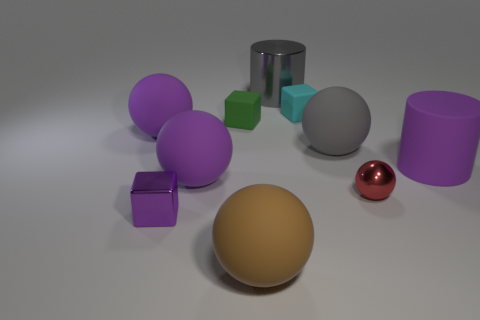What material is the green object?
Make the answer very short. Rubber. What is the material of the gray object that is on the right side of the large gray metal cylinder?
Provide a short and direct response. Rubber. Is there any other thing that is made of the same material as the red ball?
Your response must be concise. Yes. Is the number of big cylinders that are in front of the rubber cylinder greater than the number of tiny gray cylinders?
Your response must be concise. No. Are there any small cyan matte cubes on the right side of the tiny matte thing right of the gray thing that is behind the small green thing?
Make the answer very short. No. Are there any blocks left of the brown sphere?
Your answer should be very brief. Yes. How many matte blocks have the same color as the large shiny cylinder?
Your answer should be compact. 0. There is a gray thing that is the same material as the large brown thing; what size is it?
Provide a succinct answer. Large. There is a cube in front of the big purple sphere that is in front of the cylinder right of the gray sphere; what size is it?
Keep it short and to the point. Small. What is the size of the cylinder in front of the large gray rubber sphere?
Make the answer very short. Large. 